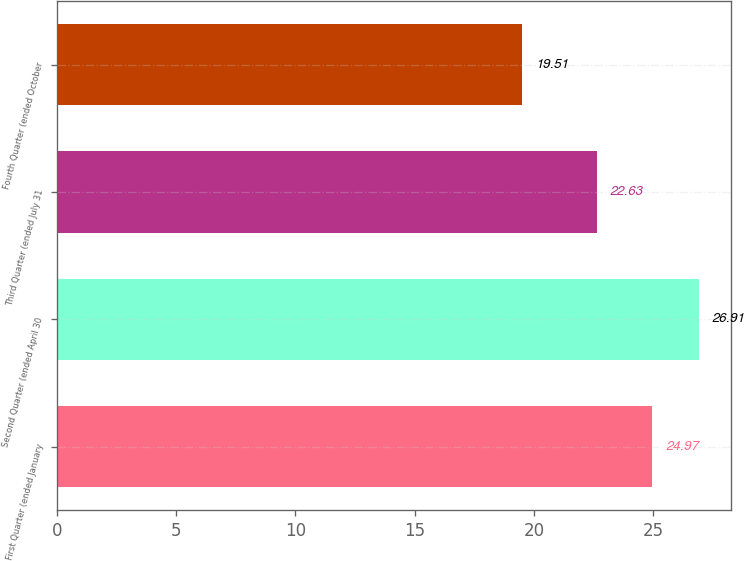Convert chart to OTSL. <chart><loc_0><loc_0><loc_500><loc_500><bar_chart><fcel>First Quarter (ended January<fcel>Second Quarter (ended April 30<fcel>Third Quarter (ended July 31<fcel>Fourth Quarter (ended October<nl><fcel>24.97<fcel>26.91<fcel>22.63<fcel>19.51<nl></chart> 